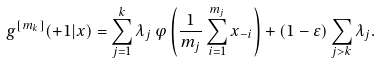Convert formula to latex. <formula><loc_0><loc_0><loc_500><loc_500>g ^ { [ m _ { k } ] } ( + 1 | x ) = \sum _ { j = 1 } ^ { k } \lambda _ { j } \, \varphi \left ( \frac { 1 } { m _ { j } } \sum _ { i = 1 } ^ { m _ { j } } x _ { - i } \right ) + ( 1 - \varepsilon ) \sum _ { j > k } \lambda _ { j } .</formula> 